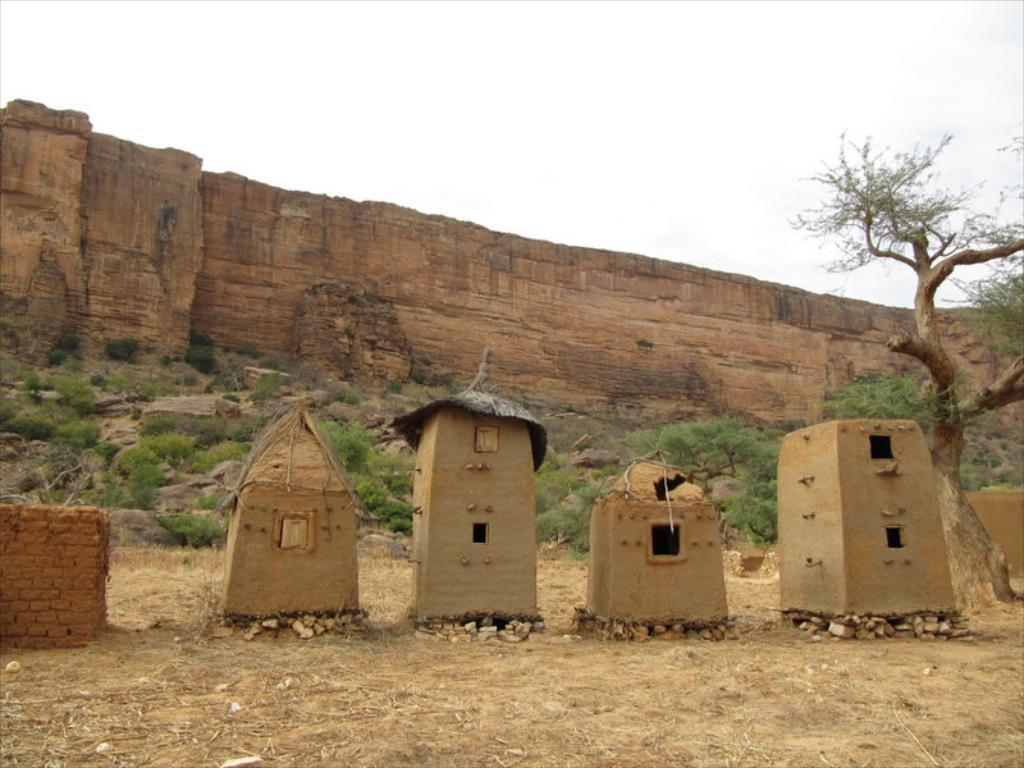What type of structures are visible in the image? There are huts in the image. What can be seen in the background of the image? There are trees and rocks in the background of the image. What time is indicated by the bell in the image? There is no bell present in the image. 